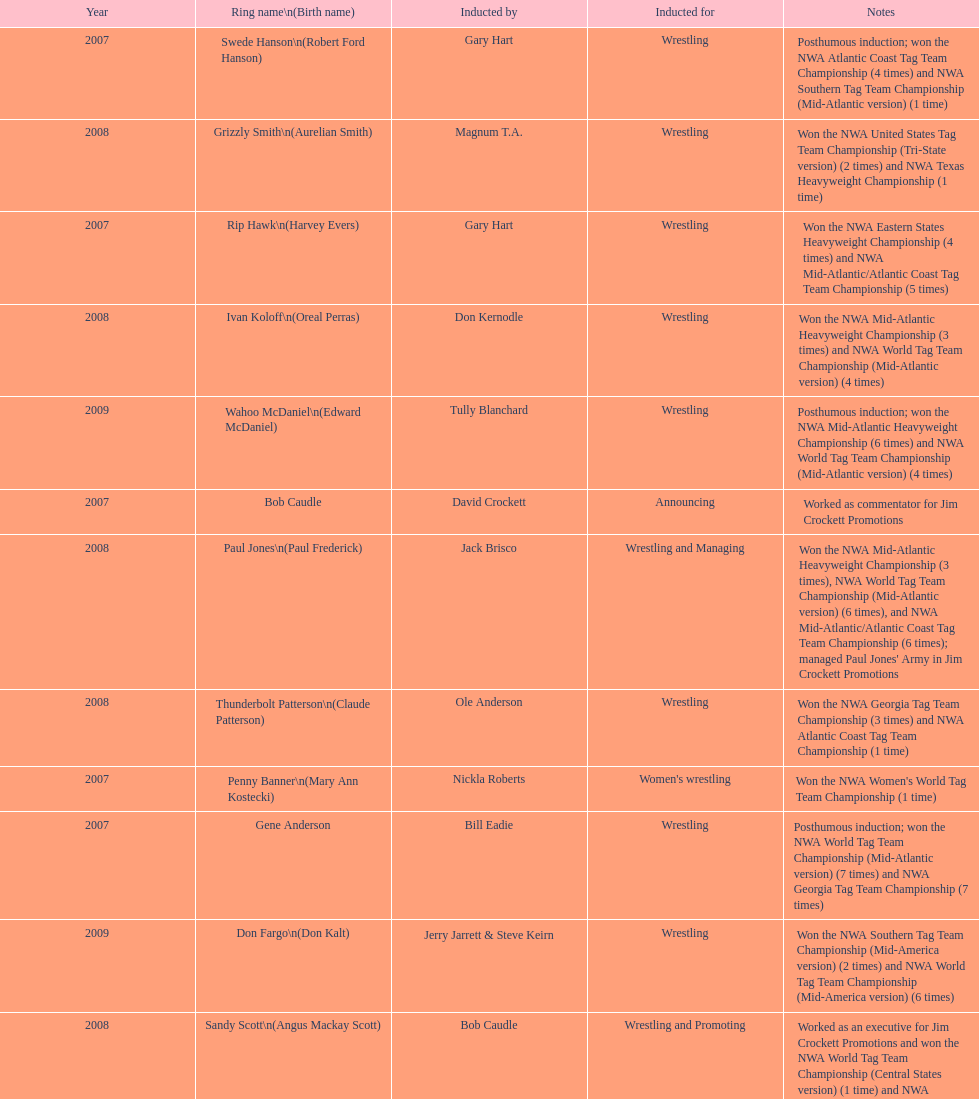Who was the only person to be inducted for wrestling and managing? Paul Jones. 